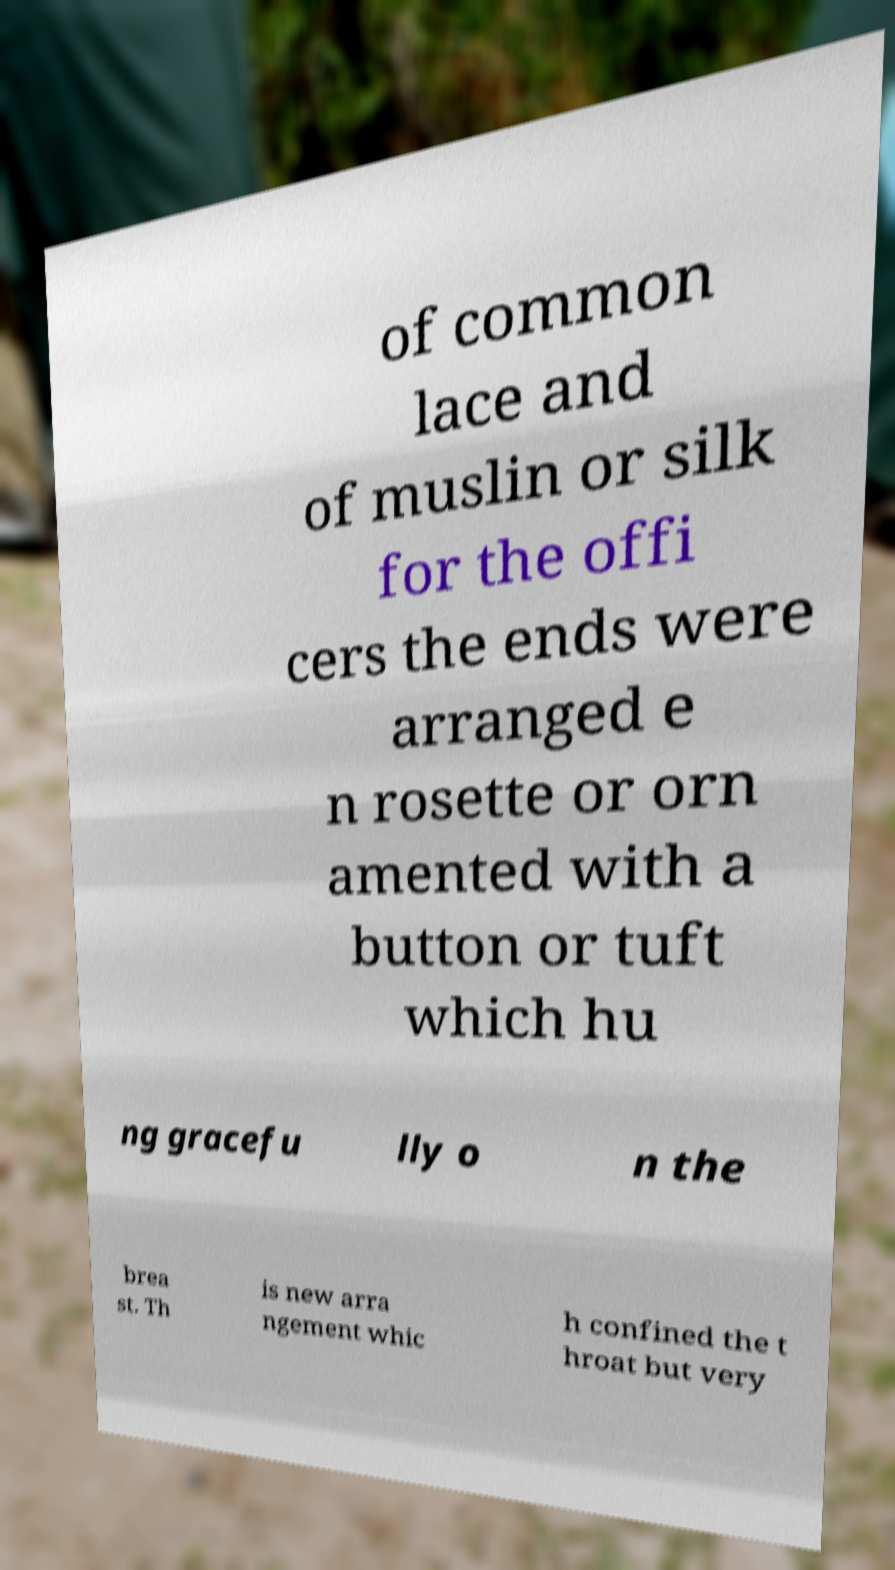Please identify and transcribe the text found in this image. of common lace and of muslin or silk for the offi cers the ends were arranged e n rosette or orn amented with a button or tuft which hu ng gracefu lly o n the brea st. Th is new arra ngement whic h confined the t hroat but very 